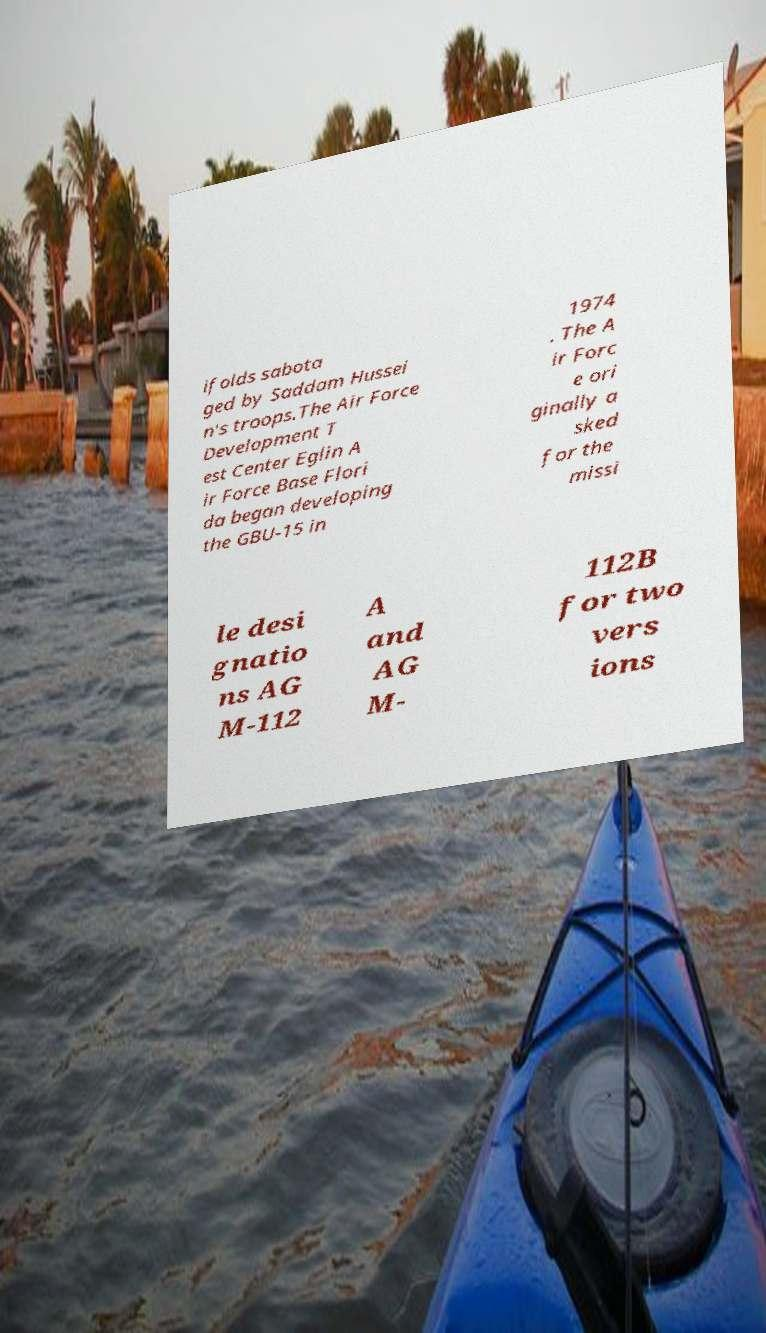I need the written content from this picture converted into text. Can you do that? ifolds sabota ged by Saddam Hussei n's troops.The Air Force Development T est Center Eglin A ir Force Base Flori da began developing the GBU-15 in 1974 . The A ir Forc e ori ginally a sked for the missi le desi gnatio ns AG M-112 A and AG M- 112B for two vers ions 